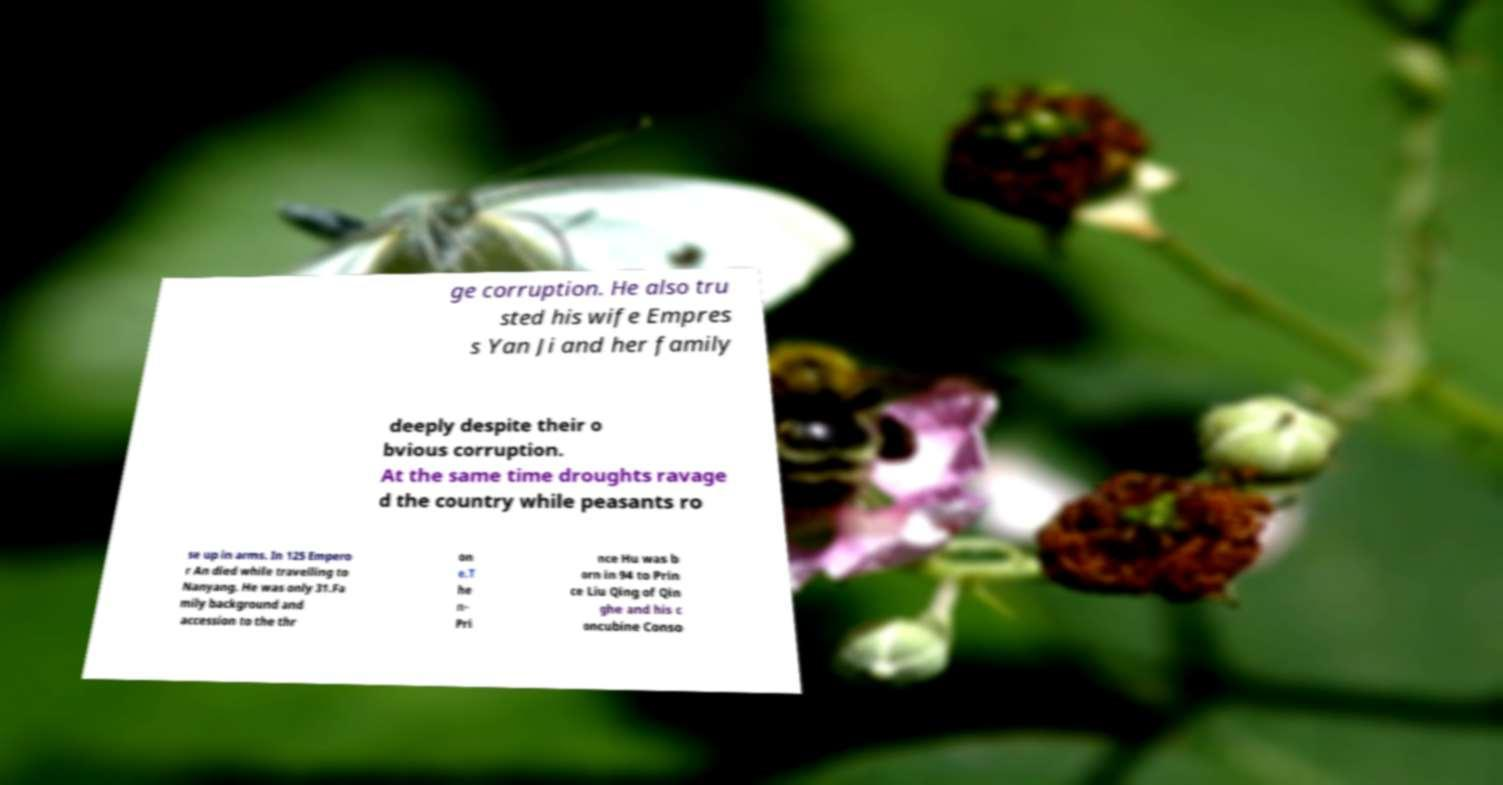Can you accurately transcribe the text from the provided image for me? ge corruption. He also tru sted his wife Empres s Yan Ji and her family deeply despite their o bvious corruption. At the same time droughts ravage d the country while peasants ro se up in arms. In 125 Empero r An died while travelling to Nanyang. He was only 31.Fa mily background and accession to the thr on e.T he n- Pri nce Hu was b orn in 94 to Prin ce Liu Qing of Qin ghe and his c oncubine Conso 